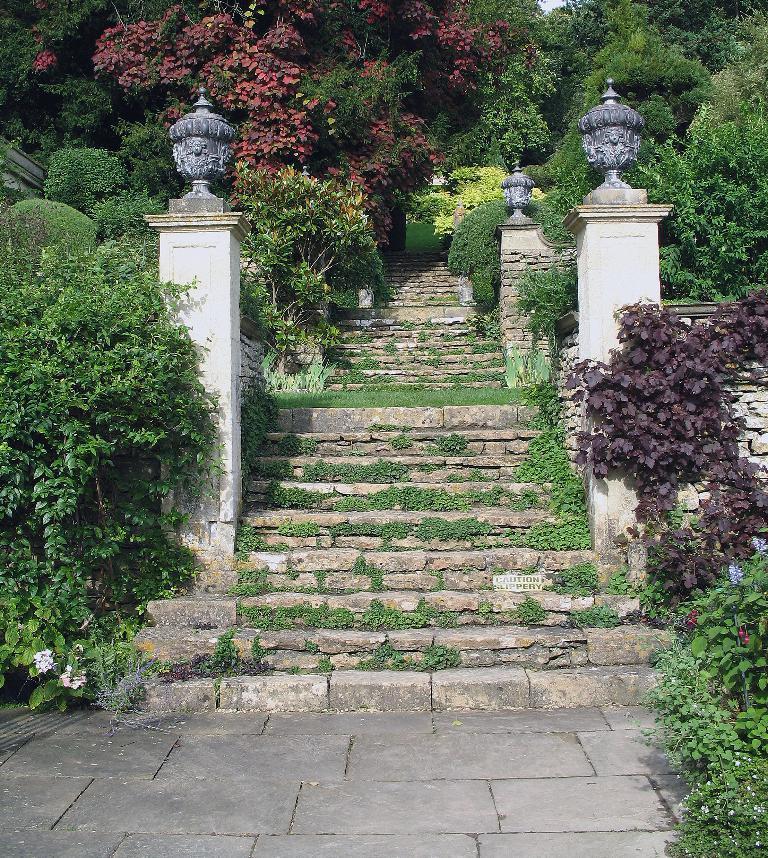Please provide a concise description of this image. In this image we can see some trees and plants, at left and right side of the image and at the middle of the image we can see walkway there are some walls on which there are lamps. 